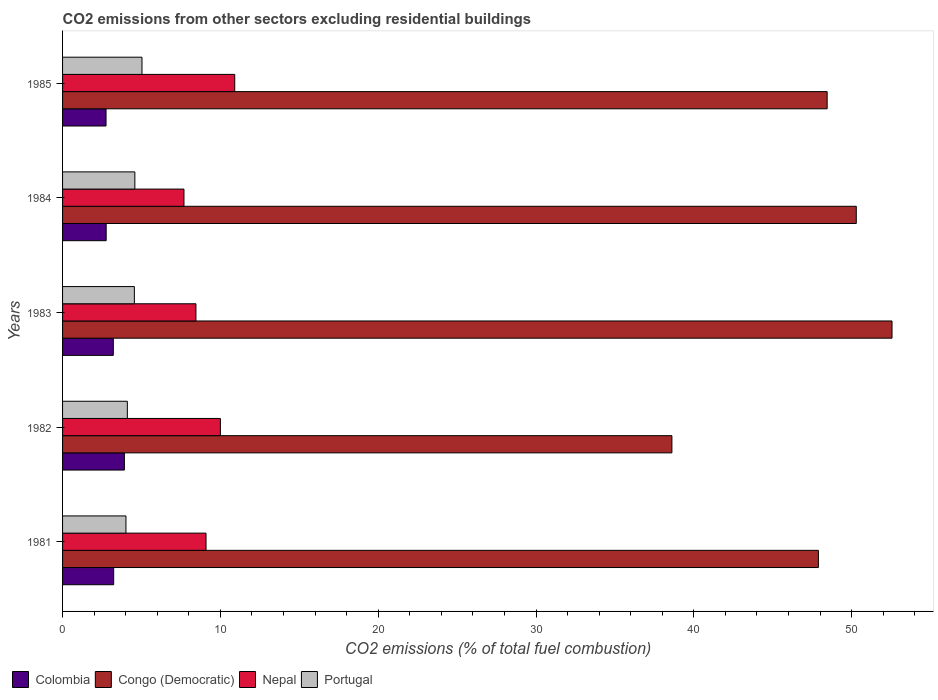How many groups of bars are there?
Ensure brevity in your answer.  5. How many bars are there on the 1st tick from the top?
Provide a succinct answer. 4. In how many cases, is the number of bars for a given year not equal to the number of legend labels?
Your answer should be compact. 0. What is the total CO2 emitted in Portugal in 1981?
Make the answer very short. 4.02. Across all years, what is the maximum total CO2 emitted in Nepal?
Provide a short and direct response. 10.91. Across all years, what is the minimum total CO2 emitted in Colombia?
Make the answer very short. 2.75. In which year was the total CO2 emitted in Portugal maximum?
Your answer should be very brief. 1985. In which year was the total CO2 emitted in Colombia minimum?
Offer a terse response. 1985. What is the total total CO2 emitted in Portugal in the graph?
Keep it short and to the point. 22.28. What is the difference between the total CO2 emitted in Colombia in 1984 and that in 1985?
Make the answer very short. 0.01. What is the difference between the total CO2 emitted in Congo (Democratic) in 1985 and the total CO2 emitted in Nepal in 1983?
Your answer should be very brief. 40. What is the average total CO2 emitted in Nepal per year?
Make the answer very short. 9.23. In the year 1985, what is the difference between the total CO2 emitted in Congo (Democratic) and total CO2 emitted in Nepal?
Your answer should be compact. 37.54. In how many years, is the total CO2 emitted in Congo (Democratic) greater than 50 ?
Ensure brevity in your answer.  2. What is the ratio of the total CO2 emitted in Congo (Democratic) in 1981 to that in 1984?
Give a very brief answer. 0.95. Is the difference between the total CO2 emitted in Congo (Democratic) in 1983 and 1985 greater than the difference between the total CO2 emitted in Nepal in 1983 and 1985?
Your response must be concise. Yes. What is the difference between the highest and the second highest total CO2 emitted in Colombia?
Your answer should be compact. 0.68. What is the difference between the highest and the lowest total CO2 emitted in Colombia?
Keep it short and to the point. 1.16. In how many years, is the total CO2 emitted in Nepal greater than the average total CO2 emitted in Nepal taken over all years?
Give a very brief answer. 2. What does the 3rd bar from the top in 1981 represents?
Your answer should be compact. Congo (Democratic). What does the 3rd bar from the bottom in 1982 represents?
Your response must be concise. Nepal. Is it the case that in every year, the sum of the total CO2 emitted in Portugal and total CO2 emitted in Congo (Democratic) is greater than the total CO2 emitted in Colombia?
Give a very brief answer. Yes. How many bars are there?
Make the answer very short. 20. How many years are there in the graph?
Provide a short and direct response. 5. Does the graph contain any zero values?
Offer a very short reply. No. How are the legend labels stacked?
Provide a succinct answer. Horizontal. What is the title of the graph?
Keep it short and to the point. CO2 emissions from other sectors excluding residential buildings. What is the label or title of the X-axis?
Offer a very short reply. CO2 emissions (% of total fuel combustion). What is the CO2 emissions (% of total fuel combustion) in Colombia in 1981?
Your response must be concise. 3.24. What is the CO2 emissions (% of total fuel combustion) in Congo (Democratic) in 1981?
Make the answer very short. 47.89. What is the CO2 emissions (% of total fuel combustion) of Nepal in 1981?
Your response must be concise. 9.09. What is the CO2 emissions (% of total fuel combustion) of Portugal in 1981?
Provide a succinct answer. 4.02. What is the CO2 emissions (% of total fuel combustion) of Colombia in 1982?
Offer a terse response. 3.92. What is the CO2 emissions (% of total fuel combustion) of Congo (Democratic) in 1982?
Provide a short and direct response. 38.61. What is the CO2 emissions (% of total fuel combustion) in Nepal in 1982?
Your response must be concise. 10. What is the CO2 emissions (% of total fuel combustion) in Portugal in 1982?
Give a very brief answer. 4.1. What is the CO2 emissions (% of total fuel combustion) of Colombia in 1983?
Your answer should be compact. 3.22. What is the CO2 emissions (% of total fuel combustion) of Congo (Democratic) in 1983?
Your response must be concise. 52.56. What is the CO2 emissions (% of total fuel combustion) of Nepal in 1983?
Keep it short and to the point. 8.45. What is the CO2 emissions (% of total fuel combustion) in Portugal in 1983?
Your answer should be very brief. 4.55. What is the CO2 emissions (% of total fuel combustion) of Colombia in 1984?
Keep it short and to the point. 2.76. What is the CO2 emissions (% of total fuel combustion) in Congo (Democratic) in 1984?
Provide a succinct answer. 50.29. What is the CO2 emissions (% of total fuel combustion) of Nepal in 1984?
Give a very brief answer. 7.69. What is the CO2 emissions (% of total fuel combustion) of Portugal in 1984?
Offer a terse response. 4.58. What is the CO2 emissions (% of total fuel combustion) in Colombia in 1985?
Your response must be concise. 2.75. What is the CO2 emissions (% of total fuel combustion) of Congo (Democratic) in 1985?
Offer a terse response. 48.45. What is the CO2 emissions (% of total fuel combustion) of Nepal in 1985?
Offer a very short reply. 10.91. What is the CO2 emissions (% of total fuel combustion) in Portugal in 1985?
Your answer should be compact. 5.03. Across all years, what is the maximum CO2 emissions (% of total fuel combustion) of Colombia?
Offer a terse response. 3.92. Across all years, what is the maximum CO2 emissions (% of total fuel combustion) of Congo (Democratic)?
Offer a terse response. 52.56. Across all years, what is the maximum CO2 emissions (% of total fuel combustion) of Nepal?
Ensure brevity in your answer.  10.91. Across all years, what is the maximum CO2 emissions (% of total fuel combustion) of Portugal?
Offer a very short reply. 5.03. Across all years, what is the minimum CO2 emissions (% of total fuel combustion) in Colombia?
Ensure brevity in your answer.  2.75. Across all years, what is the minimum CO2 emissions (% of total fuel combustion) of Congo (Democratic)?
Offer a terse response. 38.61. Across all years, what is the minimum CO2 emissions (% of total fuel combustion) in Nepal?
Offer a very short reply. 7.69. Across all years, what is the minimum CO2 emissions (% of total fuel combustion) in Portugal?
Your answer should be compact. 4.02. What is the total CO2 emissions (% of total fuel combustion) of Colombia in the graph?
Ensure brevity in your answer.  15.89. What is the total CO2 emissions (% of total fuel combustion) of Congo (Democratic) in the graph?
Ensure brevity in your answer.  237.8. What is the total CO2 emissions (% of total fuel combustion) in Nepal in the graph?
Provide a succinct answer. 46.14. What is the total CO2 emissions (% of total fuel combustion) in Portugal in the graph?
Provide a succinct answer. 22.28. What is the difference between the CO2 emissions (% of total fuel combustion) of Colombia in 1981 and that in 1982?
Your answer should be very brief. -0.68. What is the difference between the CO2 emissions (% of total fuel combustion) in Congo (Democratic) in 1981 and that in 1982?
Ensure brevity in your answer.  9.28. What is the difference between the CO2 emissions (% of total fuel combustion) of Nepal in 1981 and that in 1982?
Ensure brevity in your answer.  -0.91. What is the difference between the CO2 emissions (% of total fuel combustion) in Portugal in 1981 and that in 1982?
Provide a succinct answer. -0.09. What is the difference between the CO2 emissions (% of total fuel combustion) in Colombia in 1981 and that in 1983?
Keep it short and to the point. 0.02. What is the difference between the CO2 emissions (% of total fuel combustion) of Congo (Democratic) in 1981 and that in 1983?
Your response must be concise. -4.67. What is the difference between the CO2 emissions (% of total fuel combustion) of Nepal in 1981 and that in 1983?
Provide a short and direct response. 0.64. What is the difference between the CO2 emissions (% of total fuel combustion) of Portugal in 1981 and that in 1983?
Keep it short and to the point. -0.53. What is the difference between the CO2 emissions (% of total fuel combustion) of Colombia in 1981 and that in 1984?
Your answer should be very brief. 0.48. What is the difference between the CO2 emissions (% of total fuel combustion) of Congo (Democratic) in 1981 and that in 1984?
Offer a terse response. -2.4. What is the difference between the CO2 emissions (% of total fuel combustion) of Nepal in 1981 and that in 1984?
Offer a terse response. 1.4. What is the difference between the CO2 emissions (% of total fuel combustion) of Portugal in 1981 and that in 1984?
Your answer should be very brief. -0.56. What is the difference between the CO2 emissions (% of total fuel combustion) of Colombia in 1981 and that in 1985?
Ensure brevity in your answer.  0.48. What is the difference between the CO2 emissions (% of total fuel combustion) of Congo (Democratic) in 1981 and that in 1985?
Make the answer very short. -0.56. What is the difference between the CO2 emissions (% of total fuel combustion) of Nepal in 1981 and that in 1985?
Offer a very short reply. -1.82. What is the difference between the CO2 emissions (% of total fuel combustion) in Portugal in 1981 and that in 1985?
Make the answer very short. -1.02. What is the difference between the CO2 emissions (% of total fuel combustion) in Colombia in 1982 and that in 1983?
Provide a short and direct response. 0.7. What is the difference between the CO2 emissions (% of total fuel combustion) in Congo (Democratic) in 1982 and that in 1983?
Your answer should be compact. -13.95. What is the difference between the CO2 emissions (% of total fuel combustion) in Nepal in 1982 and that in 1983?
Provide a short and direct response. 1.55. What is the difference between the CO2 emissions (% of total fuel combustion) of Portugal in 1982 and that in 1983?
Your response must be concise. -0.44. What is the difference between the CO2 emissions (% of total fuel combustion) in Colombia in 1982 and that in 1984?
Your answer should be compact. 1.15. What is the difference between the CO2 emissions (% of total fuel combustion) of Congo (Democratic) in 1982 and that in 1984?
Give a very brief answer. -11.68. What is the difference between the CO2 emissions (% of total fuel combustion) of Nepal in 1982 and that in 1984?
Ensure brevity in your answer.  2.31. What is the difference between the CO2 emissions (% of total fuel combustion) of Portugal in 1982 and that in 1984?
Provide a succinct answer. -0.48. What is the difference between the CO2 emissions (% of total fuel combustion) of Colombia in 1982 and that in 1985?
Ensure brevity in your answer.  1.16. What is the difference between the CO2 emissions (% of total fuel combustion) in Congo (Democratic) in 1982 and that in 1985?
Make the answer very short. -9.84. What is the difference between the CO2 emissions (% of total fuel combustion) in Nepal in 1982 and that in 1985?
Offer a very short reply. -0.91. What is the difference between the CO2 emissions (% of total fuel combustion) of Portugal in 1982 and that in 1985?
Ensure brevity in your answer.  -0.93. What is the difference between the CO2 emissions (% of total fuel combustion) in Colombia in 1983 and that in 1984?
Provide a succinct answer. 0.45. What is the difference between the CO2 emissions (% of total fuel combustion) of Congo (Democratic) in 1983 and that in 1984?
Provide a succinct answer. 2.26. What is the difference between the CO2 emissions (% of total fuel combustion) in Nepal in 1983 and that in 1984?
Provide a short and direct response. 0.76. What is the difference between the CO2 emissions (% of total fuel combustion) of Portugal in 1983 and that in 1984?
Ensure brevity in your answer.  -0.03. What is the difference between the CO2 emissions (% of total fuel combustion) in Colombia in 1983 and that in 1985?
Ensure brevity in your answer.  0.46. What is the difference between the CO2 emissions (% of total fuel combustion) in Congo (Democratic) in 1983 and that in 1985?
Offer a very short reply. 4.11. What is the difference between the CO2 emissions (% of total fuel combustion) of Nepal in 1983 and that in 1985?
Make the answer very short. -2.46. What is the difference between the CO2 emissions (% of total fuel combustion) in Portugal in 1983 and that in 1985?
Give a very brief answer. -0.48. What is the difference between the CO2 emissions (% of total fuel combustion) in Colombia in 1984 and that in 1985?
Keep it short and to the point. 0.01. What is the difference between the CO2 emissions (% of total fuel combustion) of Congo (Democratic) in 1984 and that in 1985?
Your answer should be very brief. 1.85. What is the difference between the CO2 emissions (% of total fuel combustion) in Nepal in 1984 and that in 1985?
Offer a very short reply. -3.22. What is the difference between the CO2 emissions (% of total fuel combustion) in Portugal in 1984 and that in 1985?
Provide a short and direct response. -0.45. What is the difference between the CO2 emissions (% of total fuel combustion) of Colombia in 1981 and the CO2 emissions (% of total fuel combustion) of Congo (Democratic) in 1982?
Provide a succinct answer. -35.37. What is the difference between the CO2 emissions (% of total fuel combustion) of Colombia in 1981 and the CO2 emissions (% of total fuel combustion) of Nepal in 1982?
Offer a very short reply. -6.76. What is the difference between the CO2 emissions (% of total fuel combustion) of Colombia in 1981 and the CO2 emissions (% of total fuel combustion) of Portugal in 1982?
Your answer should be compact. -0.87. What is the difference between the CO2 emissions (% of total fuel combustion) of Congo (Democratic) in 1981 and the CO2 emissions (% of total fuel combustion) of Nepal in 1982?
Ensure brevity in your answer.  37.89. What is the difference between the CO2 emissions (% of total fuel combustion) in Congo (Democratic) in 1981 and the CO2 emissions (% of total fuel combustion) in Portugal in 1982?
Your answer should be compact. 43.79. What is the difference between the CO2 emissions (% of total fuel combustion) of Nepal in 1981 and the CO2 emissions (% of total fuel combustion) of Portugal in 1982?
Provide a succinct answer. 4.99. What is the difference between the CO2 emissions (% of total fuel combustion) in Colombia in 1981 and the CO2 emissions (% of total fuel combustion) in Congo (Democratic) in 1983?
Provide a short and direct response. -49.32. What is the difference between the CO2 emissions (% of total fuel combustion) of Colombia in 1981 and the CO2 emissions (% of total fuel combustion) of Nepal in 1983?
Your answer should be compact. -5.21. What is the difference between the CO2 emissions (% of total fuel combustion) in Colombia in 1981 and the CO2 emissions (% of total fuel combustion) in Portugal in 1983?
Keep it short and to the point. -1.31. What is the difference between the CO2 emissions (% of total fuel combustion) of Congo (Democratic) in 1981 and the CO2 emissions (% of total fuel combustion) of Nepal in 1983?
Provide a short and direct response. 39.44. What is the difference between the CO2 emissions (% of total fuel combustion) in Congo (Democratic) in 1981 and the CO2 emissions (% of total fuel combustion) in Portugal in 1983?
Ensure brevity in your answer.  43.34. What is the difference between the CO2 emissions (% of total fuel combustion) in Nepal in 1981 and the CO2 emissions (% of total fuel combustion) in Portugal in 1983?
Provide a short and direct response. 4.54. What is the difference between the CO2 emissions (% of total fuel combustion) of Colombia in 1981 and the CO2 emissions (% of total fuel combustion) of Congo (Democratic) in 1984?
Your response must be concise. -47.05. What is the difference between the CO2 emissions (% of total fuel combustion) in Colombia in 1981 and the CO2 emissions (% of total fuel combustion) in Nepal in 1984?
Provide a succinct answer. -4.45. What is the difference between the CO2 emissions (% of total fuel combustion) of Colombia in 1981 and the CO2 emissions (% of total fuel combustion) of Portugal in 1984?
Your answer should be very brief. -1.34. What is the difference between the CO2 emissions (% of total fuel combustion) of Congo (Democratic) in 1981 and the CO2 emissions (% of total fuel combustion) of Nepal in 1984?
Provide a short and direct response. 40.2. What is the difference between the CO2 emissions (% of total fuel combustion) in Congo (Democratic) in 1981 and the CO2 emissions (% of total fuel combustion) in Portugal in 1984?
Your answer should be very brief. 43.31. What is the difference between the CO2 emissions (% of total fuel combustion) in Nepal in 1981 and the CO2 emissions (% of total fuel combustion) in Portugal in 1984?
Offer a terse response. 4.51. What is the difference between the CO2 emissions (% of total fuel combustion) in Colombia in 1981 and the CO2 emissions (% of total fuel combustion) in Congo (Democratic) in 1985?
Your response must be concise. -45.21. What is the difference between the CO2 emissions (% of total fuel combustion) in Colombia in 1981 and the CO2 emissions (% of total fuel combustion) in Nepal in 1985?
Offer a terse response. -7.67. What is the difference between the CO2 emissions (% of total fuel combustion) in Colombia in 1981 and the CO2 emissions (% of total fuel combustion) in Portugal in 1985?
Provide a short and direct response. -1.79. What is the difference between the CO2 emissions (% of total fuel combustion) in Congo (Democratic) in 1981 and the CO2 emissions (% of total fuel combustion) in Nepal in 1985?
Keep it short and to the point. 36.98. What is the difference between the CO2 emissions (% of total fuel combustion) of Congo (Democratic) in 1981 and the CO2 emissions (% of total fuel combustion) of Portugal in 1985?
Offer a very short reply. 42.86. What is the difference between the CO2 emissions (% of total fuel combustion) in Nepal in 1981 and the CO2 emissions (% of total fuel combustion) in Portugal in 1985?
Provide a succinct answer. 4.06. What is the difference between the CO2 emissions (% of total fuel combustion) in Colombia in 1982 and the CO2 emissions (% of total fuel combustion) in Congo (Democratic) in 1983?
Provide a short and direct response. -48.64. What is the difference between the CO2 emissions (% of total fuel combustion) in Colombia in 1982 and the CO2 emissions (% of total fuel combustion) in Nepal in 1983?
Your answer should be compact. -4.53. What is the difference between the CO2 emissions (% of total fuel combustion) of Colombia in 1982 and the CO2 emissions (% of total fuel combustion) of Portugal in 1983?
Offer a terse response. -0.63. What is the difference between the CO2 emissions (% of total fuel combustion) of Congo (Democratic) in 1982 and the CO2 emissions (% of total fuel combustion) of Nepal in 1983?
Offer a very short reply. 30.16. What is the difference between the CO2 emissions (% of total fuel combustion) of Congo (Democratic) in 1982 and the CO2 emissions (% of total fuel combustion) of Portugal in 1983?
Give a very brief answer. 34.06. What is the difference between the CO2 emissions (% of total fuel combustion) of Nepal in 1982 and the CO2 emissions (% of total fuel combustion) of Portugal in 1983?
Ensure brevity in your answer.  5.45. What is the difference between the CO2 emissions (% of total fuel combustion) in Colombia in 1982 and the CO2 emissions (% of total fuel combustion) in Congo (Democratic) in 1984?
Offer a very short reply. -46.38. What is the difference between the CO2 emissions (% of total fuel combustion) of Colombia in 1982 and the CO2 emissions (% of total fuel combustion) of Nepal in 1984?
Keep it short and to the point. -3.78. What is the difference between the CO2 emissions (% of total fuel combustion) in Colombia in 1982 and the CO2 emissions (% of total fuel combustion) in Portugal in 1984?
Provide a succinct answer. -0.66. What is the difference between the CO2 emissions (% of total fuel combustion) in Congo (Democratic) in 1982 and the CO2 emissions (% of total fuel combustion) in Nepal in 1984?
Keep it short and to the point. 30.92. What is the difference between the CO2 emissions (% of total fuel combustion) in Congo (Democratic) in 1982 and the CO2 emissions (% of total fuel combustion) in Portugal in 1984?
Your answer should be very brief. 34.03. What is the difference between the CO2 emissions (% of total fuel combustion) in Nepal in 1982 and the CO2 emissions (% of total fuel combustion) in Portugal in 1984?
Your response must be concise. 5.42. What is the difference between the CO2 emissions (% of total fuel combustion) in Colombia in 1982 and the CO2 emissions (% of total fuel combustion) in Congo (Democratic) in 1985?
Your response must be concise. -44.53. What is the difference between the CO2 emissions (% of total fuel combustion) of Colombia in 1982 and the CO2 emissions (% of total fuel combustion) of Nepal in 1985?
Your response must be concise. -6.99. What is the difference between the CO2 emissions (% of total fuel combustion) in Colombia in 1982 and the CO2 emissions (% of total fuel combustion) in Portugal in 1985?
Your answer should be very brief. -1.12. What is the difference between the CO2 emissions (% of total fuel combustion) of Congo (Democratic) in 1982 and the CO2 emissions (% of total fuel combustion) of Nepal in 1985?
Offer a terse response. 27.7. What is the difference between the CO2 emissions (% of total fuel combustion) in Congo (Democratic) in 1982 and the CO2 emissions (% of total fuel combustion) in Portugal in 1985?
Make the answer very short. 33.58. What is the difference between the CO2 emissions (% of total fuel combustion) of Nepal in 1982 and the CO2 emissions (% of total fuel combustion) of Portugal in 1985?
Your answer should be very brief. 4.97. What is the difference between the CO2 emissions (% of total fuel combustion) of Colombia in 1983 and the CO2 emissions (% of total fuel combustion) of Congo (Democratic) in 1984?
Make the answer very short. -47.08. What is the difference between the CO2 emissions (% of total fuel combustion) in Colombia in 1983 and the CO2 emissions (% of total fuel combustion) in Nepal in 1984?
Offer a very short reply. -4.48. What is the difference between the CO2 emissions (% of total fuel combustion) of Colombia in 1983 and the CO2 emissions (% of total fuel combustion) of Portugal in 1984?
Provide a short and direct response. -1.37. What is the difference between the CO2 emissions (% of total fuel combustion) in Congo (Democratic) in 1983 and the CO2 emissions (% of total fuel combustion) in Nepal in 1984?
Offer a terse response. 44.86. What is the difference between the CO2 emissions (% of total fuel combustion) of Congo (Democratic) in 1983 and the CO2 emissions (% of total fuel combustion) of Portugal in 1984?
Give a very brief answer. 47.98. What is the difference between the CO2 emissions (% of total fuel combustion) in Nepal in 1983 and the CO2 emissions (% of total fuel combustion) in Portugal in 1984?
Make the answer very short. 3.87. What is the difference between the CO2 emissions (% of total fuel combustion) in Colombia in 1983 and the CO2 emissions (% of total fuel combustion) in Congo (Democratic) in 1985?
Give a very brief answer. -45.23. What is the difference between the CO2 emissions (% of total fuel combustion) in Colombia in 1983 and the CO2 emissions (% of total fuel combustion) in Nepal in 1985?
Offer a terse response. -7.69. What is the difference between the CO2 emissions (% of total fuel combustion) of Colombia in 1983 and the CO2 emissions (% of total fuel combustion) of Portugal in 1985?
Make the answer very short. -1.82. What is the difference between the CO2 emissions (% of total fuel combustion) in Congo (Democratic) in 1983 and the CO2 emissions (% of total fuel combustion) in Nepal in 1985?
Your answer should be very brief. 41.65. What is the difference between the CO2 emissions (% of total fuel combustion) of Congo (Democratic) in 1983 and the CO2 emissions (% of total fuel combustion) of Portugal in 1985?
Keep it short and to the point. 47.52. What is the difference between the CO2 emissions (% of total fuel combustion) in Nepal in 1983 and the CO2 emissions (% of total fuel combustion) in Portugal in 1985?
Ensure brevity in your answer.  3.42. What is the difference between the CO2 emissions (% of total fuel combustion) in Colombia in 1984 and the CO2 emissions (% of total fuel combustion) in Congo (Democratic) in 1985?
Your answer should be compact. -45.68. What is the difference between the CO2 emissions (% of total fuel combustion) in Colombia in 1984 and the CO2 emissions (% of total fuel combustion) in Nepal in 1985?
Offer a very short reply. -8.15. What is the difference between the CO2 emissions (% of total fuel combustion) of Colombia in 1984 and the CO2 emissions (% of total fuel combustion) of Portugal in 1985?
Provide a succinct answer. -2.27. What is the difference between the CO2 emissions (% of total fuel combustion) in Congo (Democratic) in 1984 and the CO2 emissions (% of total fuel combustion) in Nepal in 1985?
Ensure brevity in your answer.  39.38. What is the difference between the CO2 emissions (% of total fuel combustion) of Congo (Democratic) in 1984 and the CO2 emissions (% of total fuel combustion) of Portugal in 1985?
Give a very brief answer. 45.26. What is the difference between the CO2 emissions (% of total fuel combustion) in Nepal in 1984 and the CO2 emissions (% of total fuel combustion) in Portugal in 1985?
Provide a succinct answer. 2.66. What is the average CO2 emissions (% of total fuel combustion) of Colombia per year?
Provide a short and direct response. 3.18. What is the average CO2 emissions (% of total fuel combustion) of Congo (Democratic) per year?
Your answer should be compact. 47.56. What is the average CO2 emissions (% of total fuel combustion) in Nepal per year?
Keep it short and to the point. 9.23. What is the average CO2 emissions (% of total fuel combustion) of Portugal per year?
Keep it short and to the point. 4.46. In the year 1981, what is the difference between the CO2 emissions (% of total fuel combustion) of Colombia and CO2 emissions (% of total fuel combustion) of Congo (Democratic)?
Make the answer very short. -44.65. In the year 1981, what is the difference between the CO2 emissions (% of total fuel combustion) in Colombia and CO2 emissions (% of total fuel combustion) in Nepal?
Offer a very short reply. -5.85. In the year 1981, what is the difference between the CO2 emissions (% of total fuel combustion) in Colombia and CO2 emissions (% of total fuel combustion) in Portugal?
Your answer should be very brief. -0.78. In the year 1981, what is the difference between the CO2 emissions (% of total fuel combustion) of Congo (Democratic) and CO2 emissions (% of total fuel combustion) of Nepal?
Keep it short and to the point. 38.8. In the year 1981, what is the difference between the CO2 emissions (% of total fuel combustion) in Congo (Democratic) and CO2 emissions (% of total fuel combustion) in Portugal?
Keep it short and to the point. 43.88. In the year 1981, what is the difference between the CO2 emissions (% of total fuel combustion) in Nepal and CO2 emissions (% of total fuel combustion) in Portugal?
Provide a short and direct response. 5.07. In the year 1982, what is the difference between the CO2 emissions (% of total fuel combustion) in Colombia and CO2 emissions (% of total fuel combustion) in Congo (Democratic)?
Give a very brief answer. -34.69. In the year 1982, what is the difference between the CO2 emissions (% of total fuel combustion) in Colombia and CO2 emissions (% of total fuel combustion) in Nepal?
Offer a terse response. -6.08. In the year 1982, what is the difference between the CO2 emissions (% of total fuel combustion) of Colombia and CO2 emissions (% of total fuel combustion) of Portugal?
Your answer should be very brief. -0.19. In the year 1982, what is the difference between the CO2 emissions (% of total fuel combustion) of Congo (Democratic) and CO2 emissions (% of total fuel combustion) of Nepal?
Keep it short and to the point. 28.61. In the year 1982, what is the difference between the CO2 emissions (% of total fuel combustion) of Congo (Democratic) and CO2 emissions (% of total fuel combustion) of Portugal?
Offer a terse response. 34.51. In the year 1982, what is the difference between the CO2 emissions (% of total fuel combustion) of Nepal and CO2 emissions (% of total fuel combustion) of Portugal?
Provide a succinct answer. 5.9. In the year 1983, what is the difference between the CO2 emissions (% of total fuel combustion) in Colombia and CO2 emissions (% of total fuel combustion) in Congo (Democratic)?
Your response must be concise. -49.34. In the year 1983, what is the difference between the CO2 emissions (% of total fuel combustion) of Colombia and CO2 emissions (% of total fuel combustion) of Nepal?
Offer a very short reply. -5.24. In the year 1983, what is the difference between the CO2 emissions (% of total fuel combustion) in Colombia and CO2 emissions (% of total fuel combustion) in Portugal?
Provide a short and direct response. -1.33. In the year 1983, what is the difference between the CO2 emissions (% of total fuel combustion) in Congo (Democratic) and CO2 emissions (% of total fuel combustion) in Nepal?
Make the answer very short. 44.11. In the year 1983, what is the difference between the CO2 emissions (% of total fuel combustion) in Congo (Democratic) and CO2 emissions (% of total fuel combustion) in Portugal?
Your response must be concise. 48.01. In the year 1983, what is the difference between the CO2 emissions (% of total fuel combustion) in Nepal and CO2 emissions (% of total fuel combustion) in Portugal?
Offer a very short reply. 3.9. In the year 1984, what is the difference between the CO2 emissions (% of total fuel combustion) in Colombia and CO2 emissions (% of total fuel combustion) in Congo (Democratic)?
Your answer should be compact. -47.53. In the year 1984, what is the difference between the CO2 emissions (% of total fuel combustion) in Colombia and CO2 emissions (% of total fuel combustion) in Nepal?
Your answer should be compact. -4.93. In the year 1984, what is the difference between the CO2 emissions (% of total fuel combustion) in Colombia and CO2 emissions (% of total fuel combustion) in Portugal?
Make the answer very short. -1.82. In the year 1984, what is the difference between the CO2 emissions (% of total fuel combustion) in Congo (Democratic) and CO2 emissions (% of total fuel combustion) in Nepal?
Your response must be concise. 42.6. In the year 1984, what is the difference between the CO2 emissions (% of total fuel combustion) of Congo (Democratic) and CO2 emissions (% of total fuel combustion) of Portugal?
Make the answer very short. 45.71. In the year 1984, what is the difference between the CO2 emissions (% of total fuel combustion) of Nepal and CO2 emissions (% of total fuel combustion) of Portugal?
Your answer should be very brief. 3.11. In the year 1985, what is the difference between the CO2 emissions (% of total fuel combustion) in Colombia and CO2 emissions (% of total fuel combustion) in Congo (Democratic)?
Keep it short and to the point. -45.69. In the year 1985, what is the difference between the CO2 emissions (% of total fuel combustion) of Colombia and CO2 emissions (% of total fuel combustion) of Nepal?
Give a very brief answer. -8.15. In the year 1985, what is the difference between the CO2 emissions (% of total fuel combustion) of Colombia and CO2 emissions (% of total fuel combustion) of Portugal?
Give a very brief answer. -2.28. In the year 1985, what is the difference between the CO2 emissions (% of total fuel combustion) of Congo (Democratic) and CO2 emissions (% of total fuel combustion) of Nepal?
Your response must be concise. 37.54. In the year 1985, what is the difference between the CO2 emissions (% of total fuel combustion) of Congo (Democratic) and CO2 emissions (% of total fuel combustion) of Portugal?
Ensure brevity in your answer.  43.41. In the year 1985, what is the difference between the CO2 emissions (% of total fuel combustion) in Nepal and CO2 emissions (% of total fuel combustion) in Portugal?
Make the answer very short. 5.88. What is the ratio of the CO2 emissions (% of total fuel combustion) of Colombia in 1981 to that in 1982?
Keep it short and to the point. 0.83. What is the ratio of the CO2 emissions (% of total fuel combustion) of Congo (Democratic) in 1981 to that in 1982?
Offer a very short reply. 1.24. What is the ratio of the CO2 emissions (% of total fuel combustion) of Nepal in 1981 to that in 1982?
Ensure brevity in your answer.  0.91. What is the ratio of the CO2 emissions (% of total fuel combustion) in Portugal in 1981 to that in 1982?
Offer a terse response. 0.98. What is the ratio of the CO2 emissions (% of total fuel combustion) of Colombia in 1981 to that in 1983?
Provide a succinct answer. 1.01. What is the ratio of the CO2 emissions (% of total fuel combustion) of Congo (Democratic) in 1981 to that in 1983?
Ensure brevity in your answer.  0.91. What is the ratio of the CO2 emissions (% of total fuel combustion) of Nepal in 1981 to that in 1983?
Provide a succinct answer. 1.08. What is the ratio of the CO2 emissions (% of total fuel combustion) of Portugal in 1981 to that in 1983?
Keep it short and to the point. 0.88. What is the ratio of the CO2 emissions (% of total fuel combustion) in Colombia in 1981 to that in 1984?
Your answer should be very brief. 1.17. What is the ratio of the CO2 emissions (% of total fuel combustion) in Congo (Democratic) in 1981 to that in 1984?
Keep it short and to the point. 0.95. What is the ratio of the CO2 emissions (% of total fuel combustion) in Nepal in 1981 to that in 1984?
Your answer should be compact. 1.18. What is the ratio of the CO2 emissions (% of total fuel combustion) of Portugal in 1981 to that in 1984?
Your answer should be very brief. 0.88. What is the ratio of the CO2 emissions (% of total fuel combustion) in Colombia in 1981 to that in 1985?
Ensure brevity in your answer.  1.18. What is the ratio of the CO2 emissions (% of total fuel combustion) in Portugal in 1981 to that in 1985?
Provide a short and direct response. 0.8. What is the ratio of the CO2 emissions (% of total fuel combustion) of Colombia in 1982 to that in 1983?
Give a very brief answer. 1.22. What is the ratio of the CO2 emissions (% of total fuel combustion) in Congo (Democratic) in 1982 to that in 1983?
Keep it short and to the point. 0.73. What is the ratio of the CO2 emissions (% of total fuel combustion) of Nepal in 1982 to that in 1983?
Your answer should be compact. 1.18. What is the ratio of the CO2 emissions (% of total fuel combustion) of Portugal in 1982 to that in 1983?
Your answer should be compact. 0.9. What is the ratio of the CO2 emissions (% of total fuel combustion) of Colombia in 1982 to that in 1984?
Ensure brevity in your answer.  1.42. What is the ratio of the CO2 emissions (% of total fuel combustion) in Congo (Democratic) in 1982 to that in 1984?
Keep it short and to the point. 0.77. What is the ratio of the CO2 emissions (% of total fuel combustion) of Portugal in 1982 to that in 1984?
Provide a succinct answer. 0.9. What is the ratio of the CO2 emissions (% of total fuel combustion) in Colombia in 1982 to that in 1985?
Ensure brevity in your answer.  1.42. What is the ratio of the CO2 emissions (% of total fuel combustion) of Congo (Democratic) in 1982 to that in 1985?
Provide a succinct answer. 0.8. What is the ratio of the CO2 emissions (% of total fuel combustion) in Nepal in 1982 to that in 1985?
Your response must be concise. 0.92. What is the ratio of the CO2 emissions (% of total fuel combustion) in Portugal in 1982 to that in 1985?
Your response must be concise. 0.82. What is the ratio of the CO2 emissions (% of total fuel combustion) in Colombia in 1983 to that in 1984?
Provide a short and direct response. 1.16. What is the ratio of the CO2 emissions (% of total fuel combustion) of Congo (Democratic) in 1983 to that in 1984?
Provide a short and direct response. 1.04. What is the ratio of the CO2 emissions (% of total fuel combustion) of Nepal in 1983 to that in 1984?
Make the answer very short. 1.1. What is the ratio of the CO2 emissions (% of total fuel combustion) of Portugal in 1983 to that in 1984?
Provide a short and direct response. 0.99. What is the ratio of the CO2 emissions (% of total fuel combustion) in Colombia in 1983 to that in 1985?
Your answer should be very brief. 1.17. What is the ratio of the CO2 emissions (% of total fuel combustion) of Congo (Democratic) in 1983 to that in 1985?
Your response must be concise. 1.08. What is the ratio of the CO2 emissions (% of total fuel combustion) of Nepal in 1983 to that in 1985?
Make the answer very short. 0.77. What is the ratio of the CO2 emissions (% of total fuel combustion) in Portugal in 1983 to that in 1985?
Offer a very short reply. 0.9. What is the ratio of the CO2 emissions (% of total fuel combustion) in Congo (Democratic) in 1984 to that in 1985?
Keep it short and to the point. 1.04. What is the ratio of the CO2 emissions (% of total fuel combustion) in Nepal in 1984 to that in 1985?
Provide a short and direct response. 0.71. What is the ratio of the CO2 emissions (% of total fuel combustion) of Portugal in 1984 to that in 1985?
Provide a short and direct response. 0.91. What is the difference between the highest and the second highest CO2 emissions (% of total fuel combustion) of Colombia?
Your response must be concise. 0.68. What is the difference between the highest and the second highest CO2 emissions (% of total fuel combustion) of Congo (Democratic)?
Keep it short and to the point. 2.26. What is the difference between the highest and the second highest CO2 emissions (% of total fuel combustion) in Portugal?
Make the answer very short. 0.45. What is the difference between the highest and the lowest CO2 emissions (% of total fuel combustion) in Colombia?
Offer a very short reply. 1.16. What is the difference between the highest and the lowest CO2 emissions (% of total fuel combustion) of Congo (Democratic)?
Your answer should be compact. 13.95. What is the difference between the highest and the lowest CO2 emissions (% of total fuel combustion) in Nepal?
Provide a succinct answer. 3.22. What is the difference between the highest and the lowest CO2 emissions (% of total fuel combustion) in Portugal?
Provide a succinct answer. 1.02. 